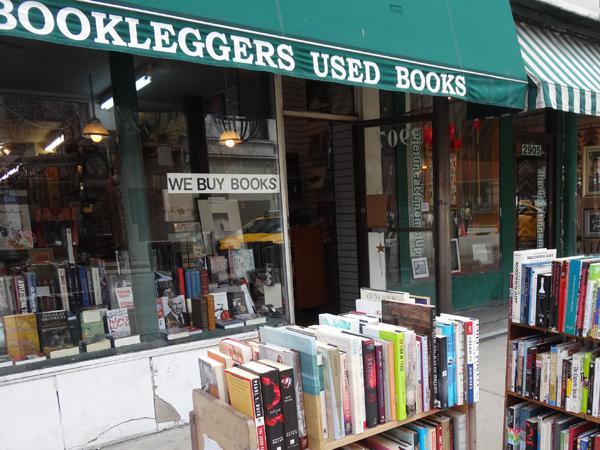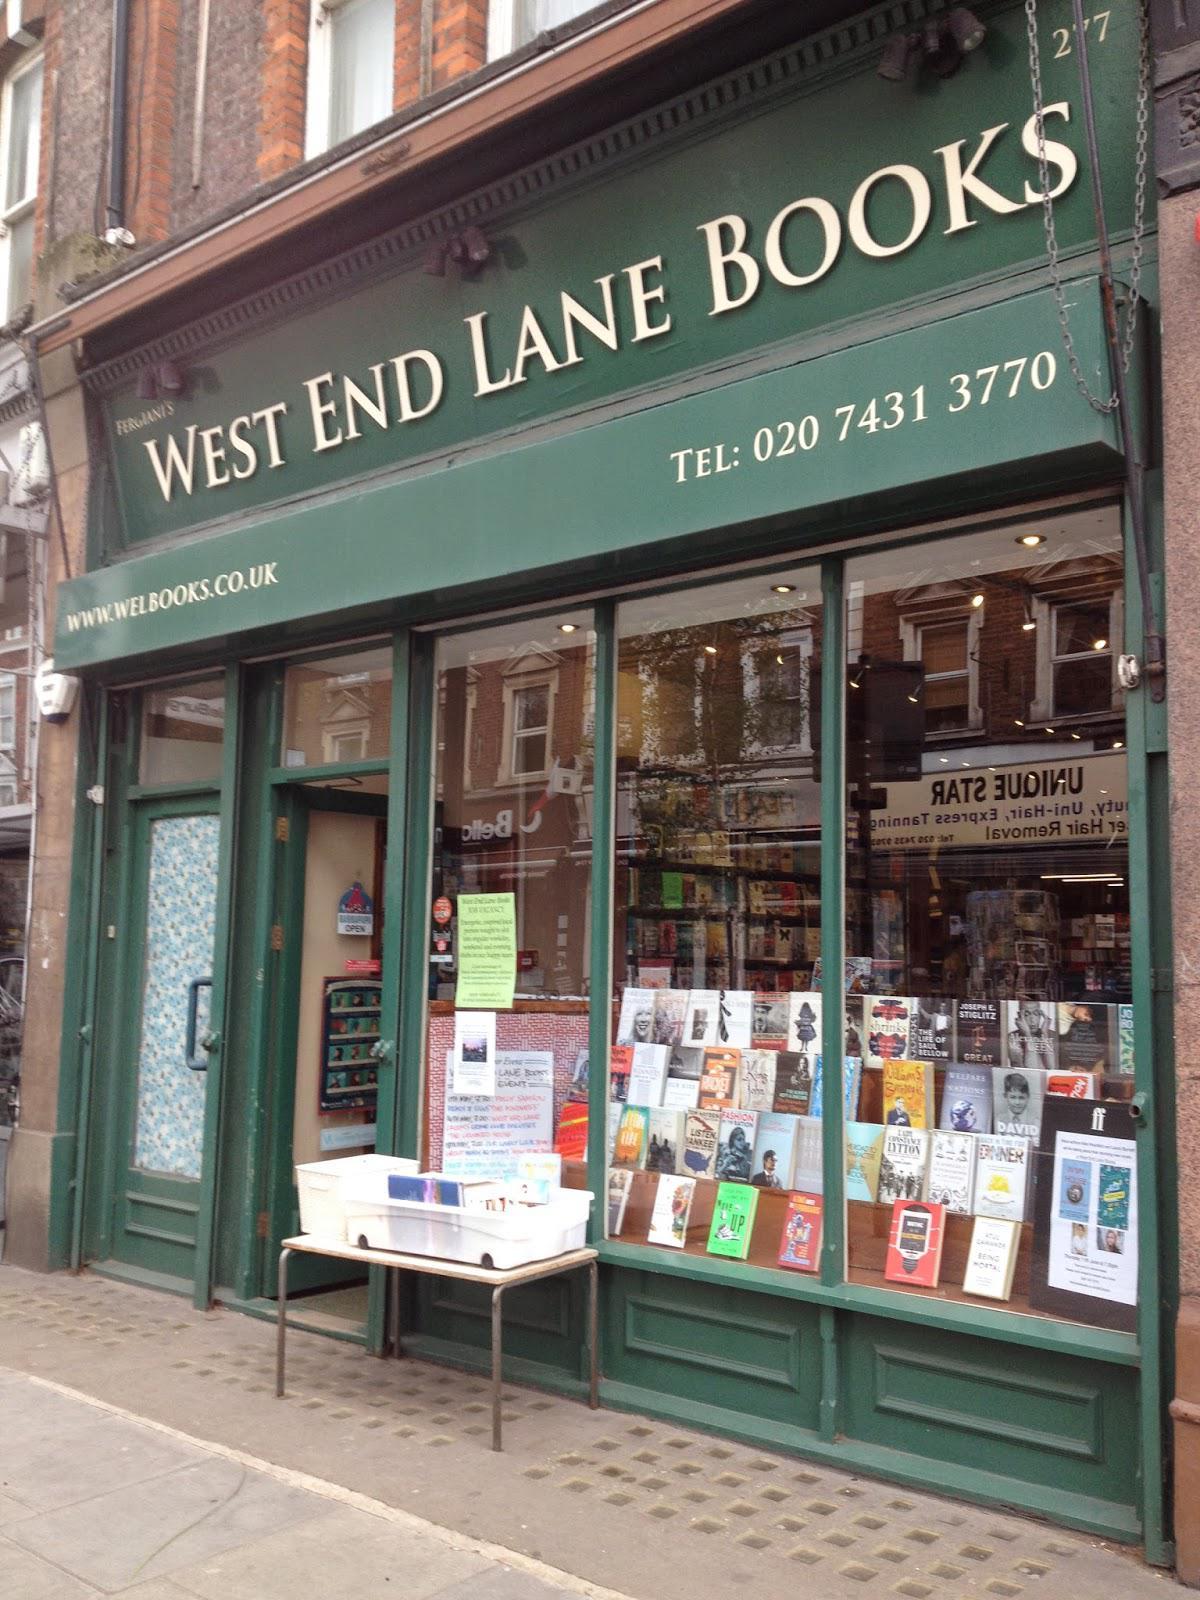The first image is the image on the left, the second image is the image on the right. Examine the images to the left and right. Is the description "there is a book shelf with books outside the front window of the book store" accurate? Answer yes or no. Yes. The first image is the image on the left, the second image is the image on the right. Given the left and right images, does the statement "Outside store front view of used bookstores." hold true? Answer yes or no. Yes. 